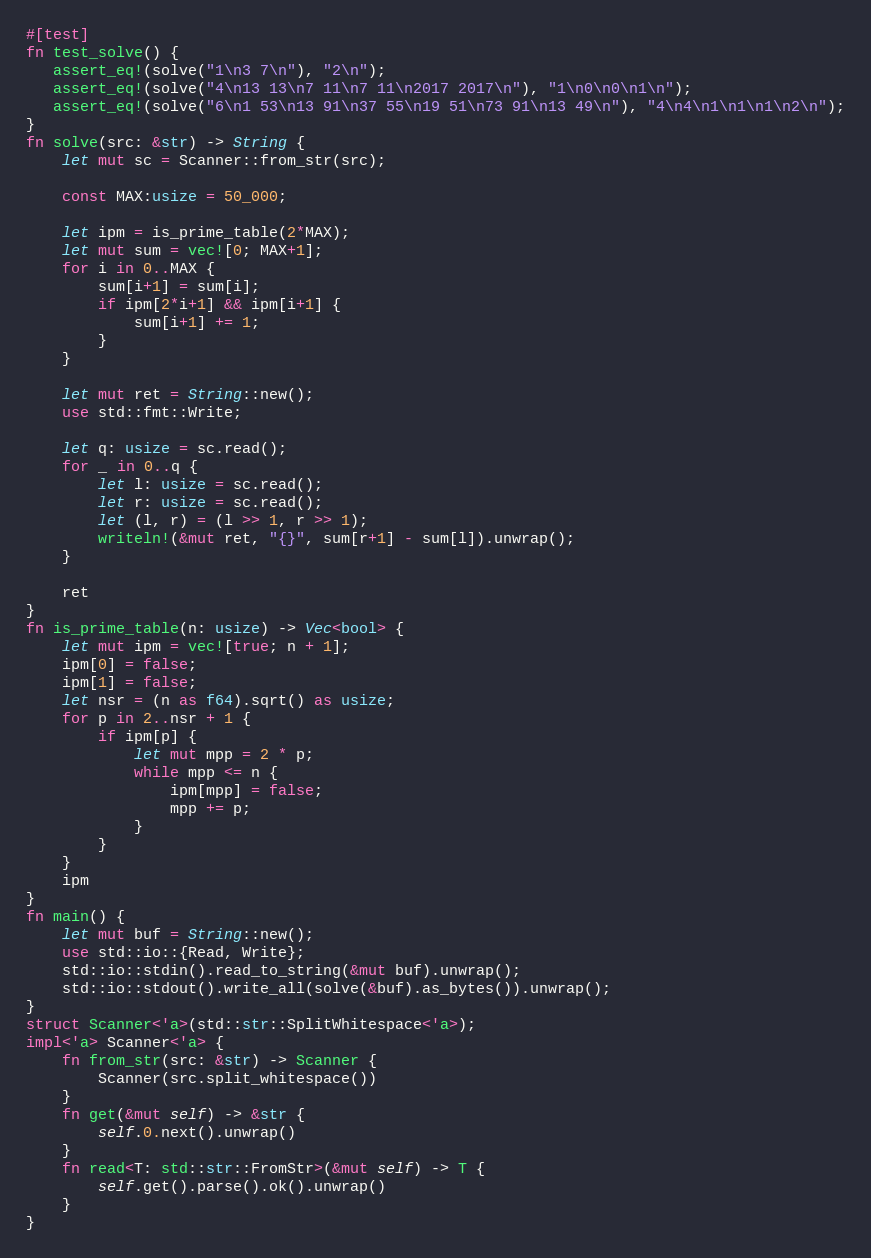<code> <loc_0><loc_0><loc_500><loc_500><_Rust_>#[test]
fn test_solve() {
   assert_eq!(solve("1\n3 7\n"), "2\n");
   assert_eq!(solve("4\n13 13\n7 11\n7 11\n2017 2017\n"), "1\n0\n0\n1\n");
   assert_eq!(solve("6\n1 53\n13 91\n37 55\n19 51\n73 91\n13 49\n"), "4\n4\n1\n1\n1\n2\n");
}
fn solve(src: &str) -> String {
    let mut sc = Scanner::from_str(src);

    const MAX:usize = 50_000;

    let ipm = is_prime_table(2*MAX);
    let mut sum = vec![0; MAX+1];
    for i in 0..MAX {
        sum[i+1] = sum[i];
        if ipm[2*i+1] && ipm[i+1] {
            sum[i+1] += 1;
        } 
    }
    
    let mut ret = String::new();
    use std::fmt::Write;
    
    let q: usize = sc.read();
    for _ in 0..q {
        let l: usize = sc.read();
        let r: usize = sc.read();
        let (l, r) = (l >> 1, r >> 1);
        writeln!(&mut ret, "{}", sum[r+1] - sum[l]).unwrap();
    }
    
    ret
}
fn is_prime_table(n: usize) -> Vec<bool> {
    let mut ipm = vec![true; n + 1];
    ipm[0] = false;
    ipm[1] = false;
    let nsr = (n as f64).sqrt() as usize;
    for p in 2..nsr + 1 {
        if ipm[p] {
            let mut mpp = 2 * p;
            while mpp <= n {
                ipm[mpp] = false;
                mpp += p;
            }
        }
    }
    ipm
}
fn main() {
    let mut buf = String::new();
    use std::io::{Read, Write};
    std::io::stdin().read_to_string(&mut buf).unwrap();
    std::io::stdout().write_all(solve(&buf).as_bytes()).unwrap();
}
struct Scanner<'a>(std::str::SplitWhitespace<'a>);
impl<'a> Scanner<'a> {
    fn from_str(src: &str) -> Scanner {
        Scanner(src.split_whitespace())
    }
    fn get(&mut self) -> &str {
        self.0.next().unwrap()
    }
    fn read<T: std::str::FromStr>(&mut self) -> T {
        self.get().parse().ok().unwrap()
    }
}</code> 